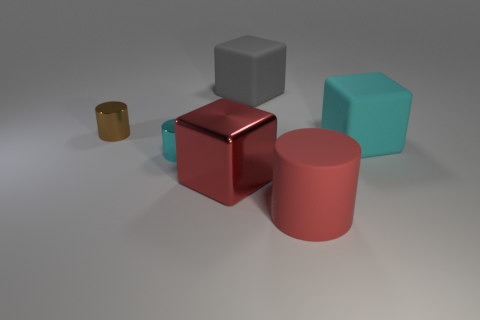Are there any tiny brown things that are in front of the cyan thing that is left of the large cube in front of the big cyan cube?
Your answer should be compact. No. What color is the big matte cylinder?
Ensure brevity in your answer.  Red. There is a red object that is to the right of the large gray matte block; is its shape the same as the big cyan thing?
Provide a short and direct response. No. What number of things are red cylinders or shiny things in front of the tiny cyan shiny thing?
Ensure brevity in your answer.  2. Is the small object that is behind the tiny cyan thing made of the same material as the large gray thing?
Ensure brevity in your answer.  No. What material is the big block that is behind the large matte block that is right of the rubber cylinder?
Your response must be concise. Rubber. Are there more red objects in front of the big red metal object than brown cylinders to the right of the brown metal cylinder?
Make the answer very short. Yes. How big is the gray matte thing?
Provide a short and direct response. Large. There is a rubber object that is in front of the metal block; is its color the same as the big metal thing?
Give a very brief answer. Yes. Are there any brown things on the right side of the big thing that is in front of the red block?
Offer a terse response. No. 